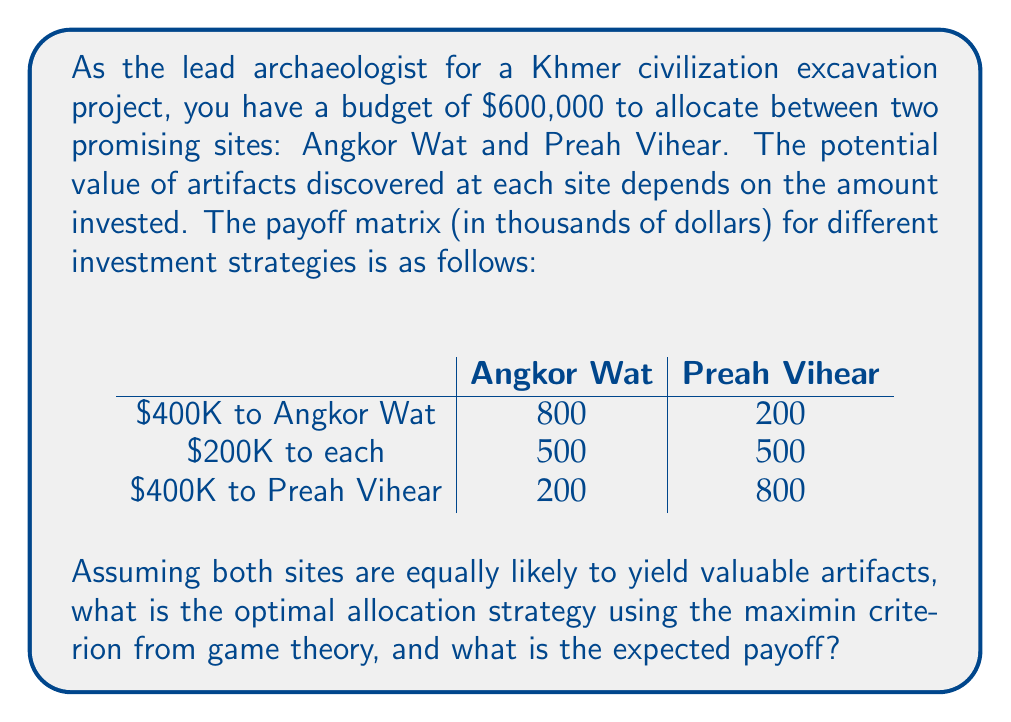Can you solve this math problem? To solve this problem using game theory's maximin criterion, we need to follow these steps:

1) First, we identify the minimum payoff for each strategy:

   - $400K to Angkor Wat: min(800, 200) = 200$
   - $200K to each: min(500, 500) = 500$
   - $400K to Preah Vihear: min(200, 800) = 200$

2) The maximin strategy is the one that gives the highest of these minimum payoffs. In this case, it's the strategy of allocating $200K to each site, with a minimum payoff of 500.

3) To calculate the expected payoff of this strategy, we need to consider the equal likelihood of valuable artifacts at each site:

   Expected Payoff = $0.5 * 500 + 0.5 * 500 = 500$

This strategy ensures a guaranteed minimum payoff of $500,000, regardless of which site turns out to be more valuable. It's a conservative approach that protects against the worst-case scenario while still allowing for potential high returns if both sites prove fruitful.

The maximin criterion is particularly useful in archaeology, where the outcome of excavations can be highly uncertain. By spreading the investment, we mitigate the risk of allocating too much to a potentially less valuable site while still maintaining the possibility of significant discoveries at both locations.
Answer: The optimal allocation strategy using the maximin criterion is to invest $200,000 in each site (Angkor Wat and Preah Vihear). The expected payoff from this strategy is $500,000. 